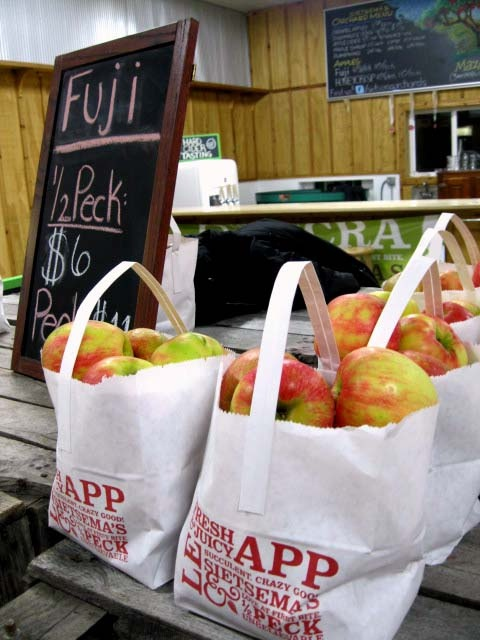Describe the objects in this image and their specific colors. I can see apple in lightgray, tan, brown, and khaki tones, apple in lightgray, tan, khaki, red, and olive tones, apple in lightgray, orange, red, and salmon tones, apple in lightgray, red, tan, and olive tones, and apple in lightgray, brown, tan, red, and salmon tones in this image. 